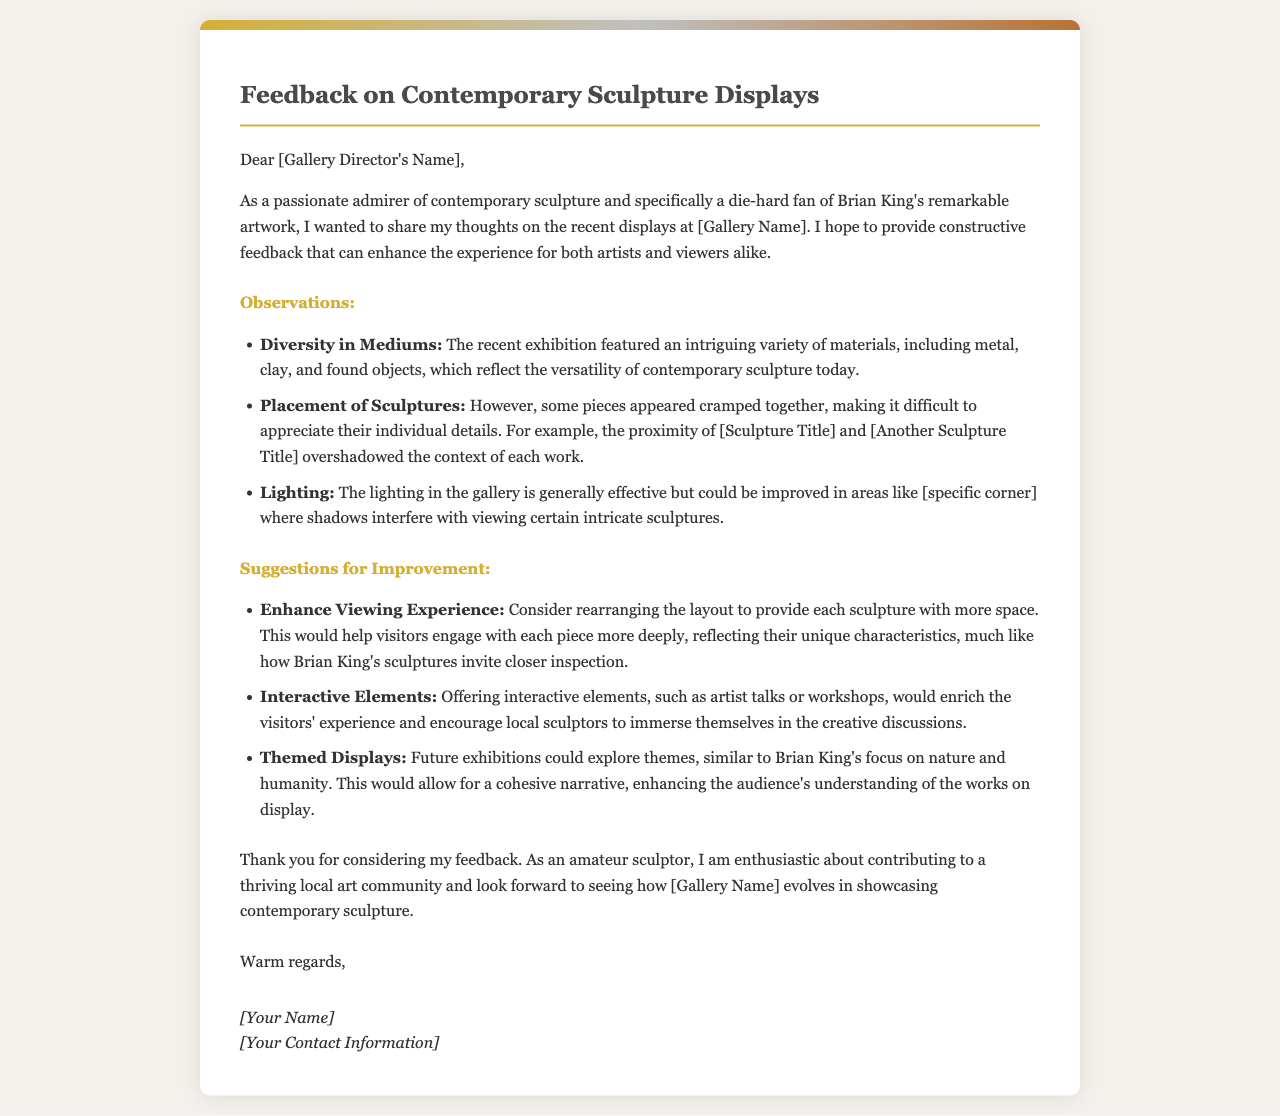What is the name of the artist mentioned in the letter? The letter highlights Brian King's artwork as a notable example of contemporary sculpture admired by the writer.
Answer: Brian King What does the writer suggest improving regarding sculpture placement? The writer notes that some sculptures are cramped, making it difficult to appreciate their details.
Answer: Provide more space What interactive elements does the letter suggest? The writer proposes offering interactive elements to enhance visitor experience and engagement with artists.
Answer: Artist talks or workshops What is a specific lighting area mentioned as needing improvement? The author points out that lighting shadows interfere with viewing sculptures in certain areas of the gallery.
Answer: Specific corner What type of feedback is being provided in the document? The document contains observations and suggestions from a passionate admirer of sculpture regarding the gallery's exhibitions.
Answer: Constructive feedback What is the purpose of the letter? The letter aims to provide observations and improvement suggestions for recent contemporary sculpture displays at the gallery.
Answer: Share thoughts What does the writer hope to contribute to through their feedback? The writer expresses enthusiasm about helping to foster a thriving local art community.
Answer: Thriving local art community In what format is the feedback presented? The feedback is presented in structured sections, including observations and suggestions for improvement.
Answer: Sections 